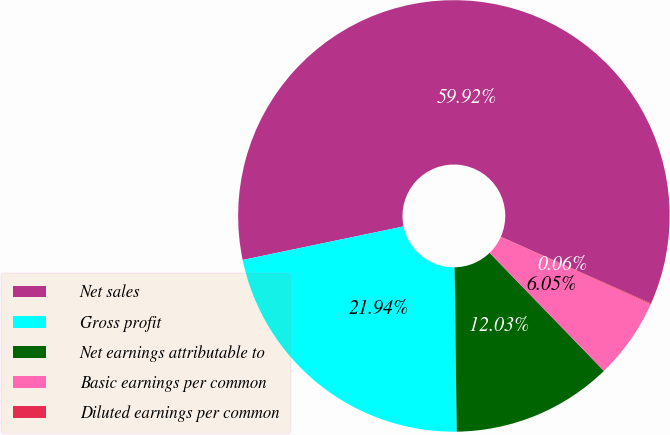Convert chart to OTSL. <chart><loc_0><loc_0><loc_500><loc_500><pie_chart><fcel>Net sales<fcel>Gross profit<fcel>Net earnings attributable to<fcel>Basic earnings per common<fcel>Diluted earnings per common<nl><fcel>59.92%<fcel>21.94%<fcel>12.03%<fcel>6.05%<fcel>0.06%<nl></chart> 